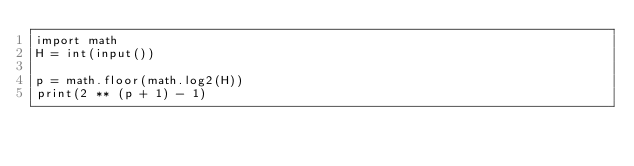Convert code to text. <code><loc_0><loc_0><loc_500><loc_500><_Python_>import math
H = int(input())

p = math.floor(math.log2(H))
print(2 ** (p + 1) - 1)</code> 